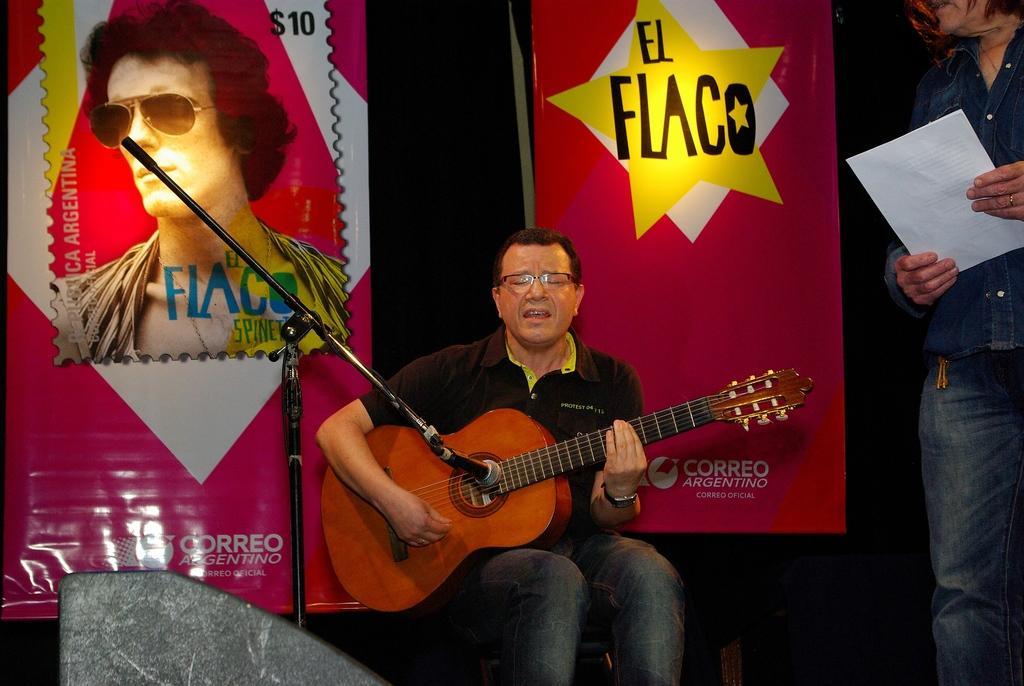Describe this image in one or two sentences. In this image I can see a person holding the guitar. To the right there is another person holding the paper. In the background there are banners. 